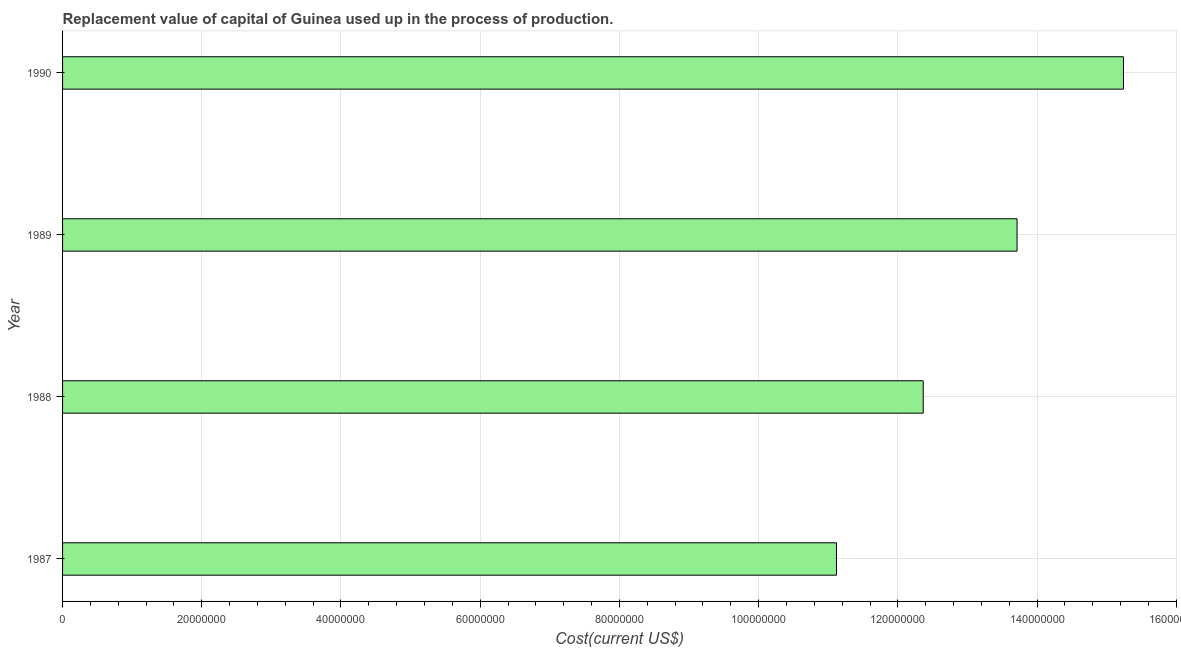What is the title of the graph?
Give a very brief answer. Replacement value of capital of Guinea used up in the process of production. What is the label or title of the X-axis?
Provide a succinct answer. Cost(current US$). What is the consumption of fixed capital in 1989?
Offer a terse response. 1.37e+08. Across all years, what is the maximum consumption of fixed capital?
Give a very brief answer. 1.52e+08. Across all years, what is the minimum consumption of fixed capital?
Offer a terse response. 1.11e+08. What is the sum of the consumption of fixed capital?
Your response must be concise. 5.24e+08. What is the difference between the consumption of fixed capital in 1989 and 1990?
Keep it short and to the point. -1.53e+07. What is the average consumption of fixed capital per year?
Offer a very short reply. 1.31e+08. What is the median consumption of fixed capital?
Give a very brief answer. 1.30e+08. In how many years, is the consumption of fixed capital greater than 88000000 US$?
Your answer should be very brief. 4. Do a majority of the years between 1988 and 1989 (inclusive) have consumption of fixed capital greater than 72000000 US$?
Make the answer very short. Yes. What is the ratio of the consumption of fixed capital in 1987 to that in 1989?
Offer a very short reply. 0.81. Is the difference between the consumption of fixed capital in 1989 and 1990 greater than the difference between any two years?
Provide a succinct answer. No. What is the difference between the highest and the second highest consumption of fixed capital?
Your answer should be compact. 1.53e+07. Is the sum of the consumption of fixed capital in 1987 and 1988 greater than the maximum consumption of fixed capital across all years?
Ensure brevity in your answer.  Yes. What is the difference between the highest and the lowest consumption of fixed capital?
Your response must be concise. 4.12e+07. In how many years, is the consumption of fixed capital greater than the average consumption of fixed capital taken over all years?
Keep it short and to the point. 2. How many bars are there?
Ensure brevity in your answer.  4. Are all the bars in the graph horizontal?
Offer a very short reply. Yes. Are the values on the major ticks of X-axis written in scientific E-notation?
Offer a terse response. No. What is the Cost(current US$) of 1987?
Make the answer very short. 1.11e+08. What is the Cost(current US$) in 1988?
Give a very brief answer. 1.24e+08. What is the Cost(current US$) of 1989?
Your answer should be very brief. 1.37e+08. What is the Cost(current US$) of 1990?
Provide a short and direct response. 1.52e+08. What is the difference between the Cost(current US$) in 1987 and 1988?
Your answer should be compact. -1.25e+07. What is the difference between the Cost(current US$) in 1987 and 1989?
Provide a short and direct response. -2.59e+07. What is the difference between the Cost(current US$) in 1987 and 1990?
Offer a very short reply. -4.12e+07. What is the difference between the Cost(current US$) in 1988 and 1989?
Keep it short and to the point. -1.35e+07. What is the difference between the Cost(current US$) in 1988 and 1990?
Ensure brevity in your answer.  -2.88e+07. What is the difference between the Cost(current US$) in 1989 and 1990?
Your answer should be compact. -1.53e+07. What is the ratio of the Cost(current US$) in 1987 to that in 1988?
Your answer should be very brief. 0.9. What is the ratio of the Cost(current US$) in 1987 to that in 1989?
Keep it short and to the point. 0.81. What is the ratio of the Cost(current US$) in 1987 to that in 1990?
Your response must be concise. 0.73. What is the ratio of the Cost(current US$) in 1988 to that in 1989?
Provide a short and direct response. 0.9. What is the ratio of the Cost(current US$) in 1988 to that in 1990?
Provide a succinct answer. 0.81. What is the ratio of the Cost(current US$) in 1989 to that in 1990?
Keep it short and to the point. 0.9. 